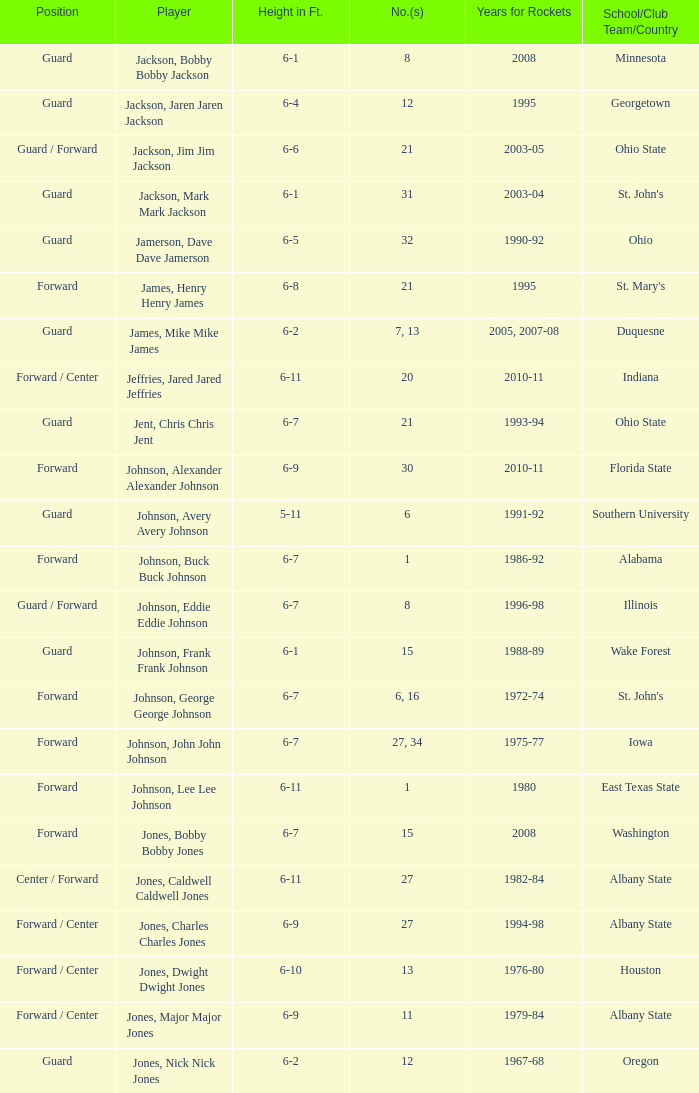How tall is the player jones, major major jones? 6-9. 